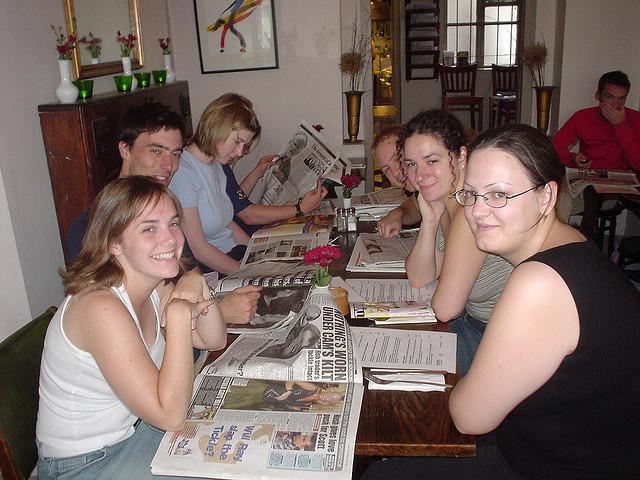How many people are reading the papers?
Give a very brief answer. 4. Is this a classroom?
Quick response, please. No. How many vases are reflected in the mirror?
Keep it brief. 1. Are both of this person's elbows on the table?
Concise answer only. Yes. 